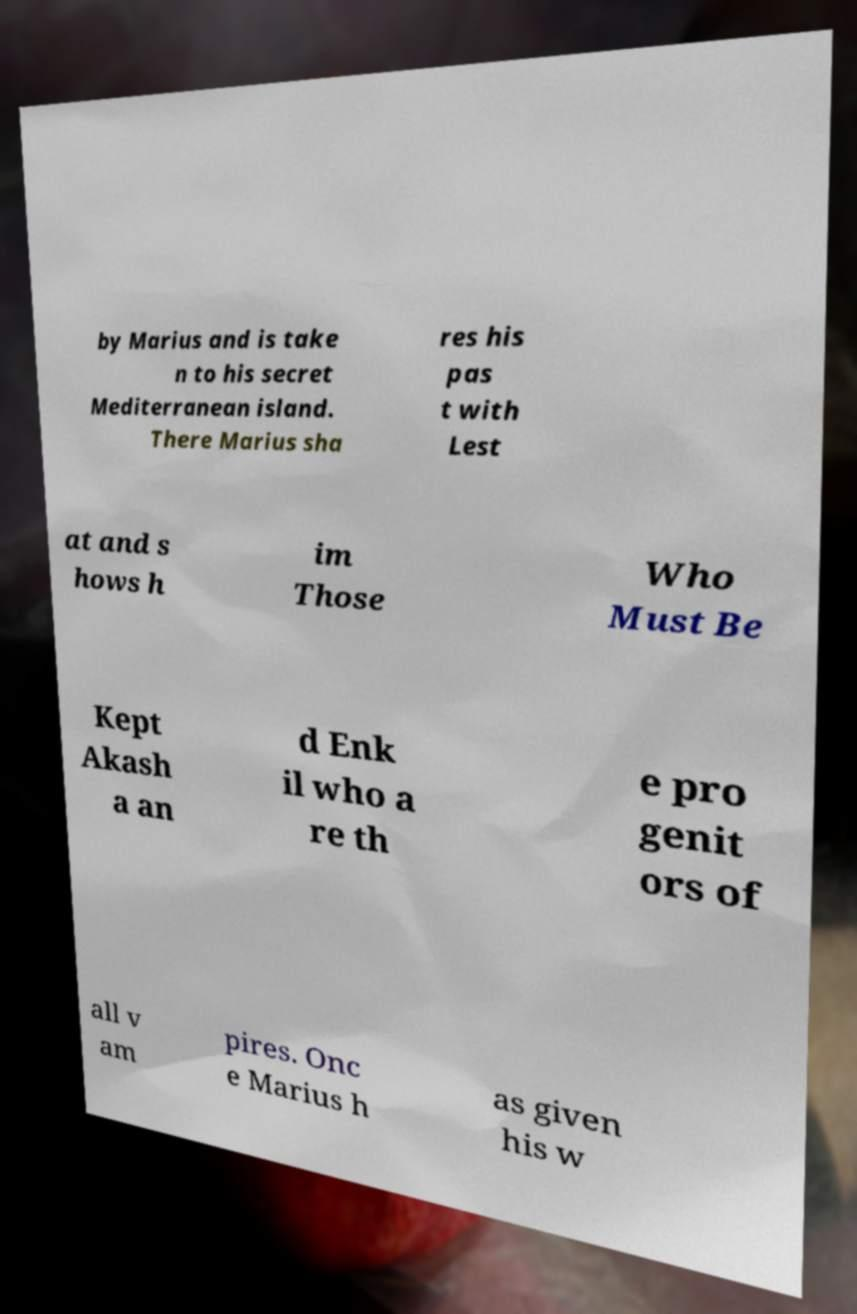Could you extract and type out the text from this image? by Marius and is take n to his secret Mediterranean island. There Marius sha res his pas t with Lest at and s hows h im Those Who Must Be Kept Akash a an d Enk il who a re th e pro genit ors of all v am pires. Onc e Marius h as given his w 